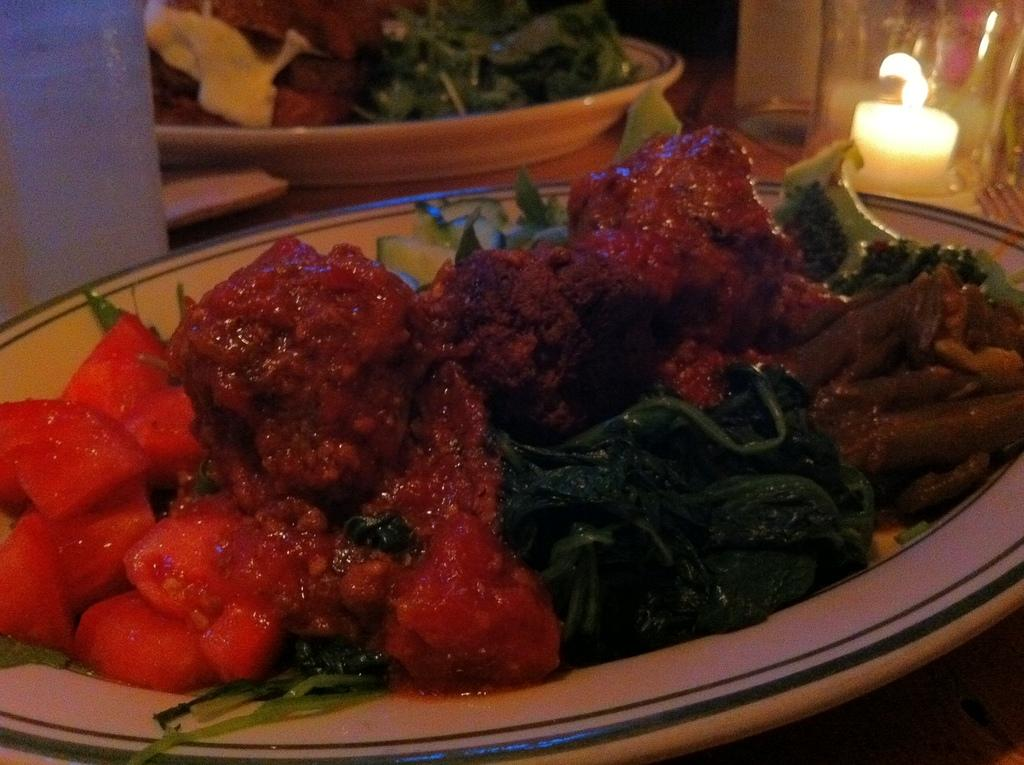What is on the plate that is visible in the image? There is food on a plate in the image. What else can be seen in the image besides the plate? There is a glass in the image. What is inside the glass? There is a candle inside the glass. What type of powder is sprinkled on the food in the image? There is no powder visible on the food in the image. How does the candle adjust its height in the image? The candle does not adjust its height in the image; it is stationary inside the glass. 